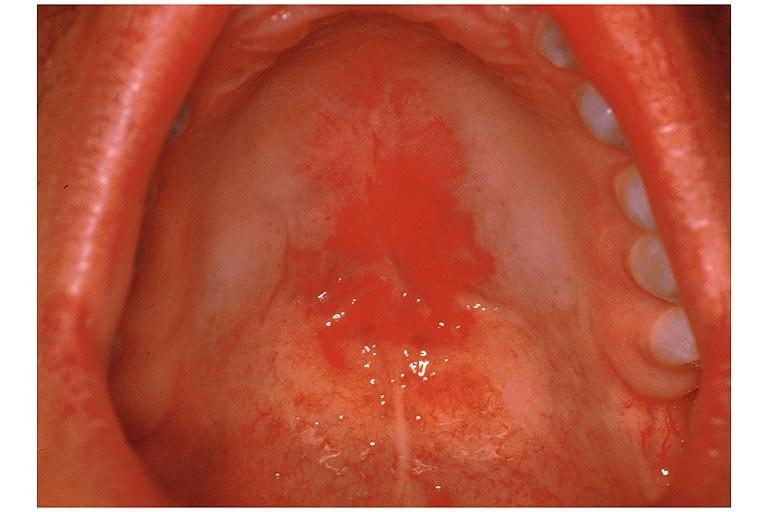does this image show candidiasis-erythematous?
Answer the question using a single word or phrase. Yes 